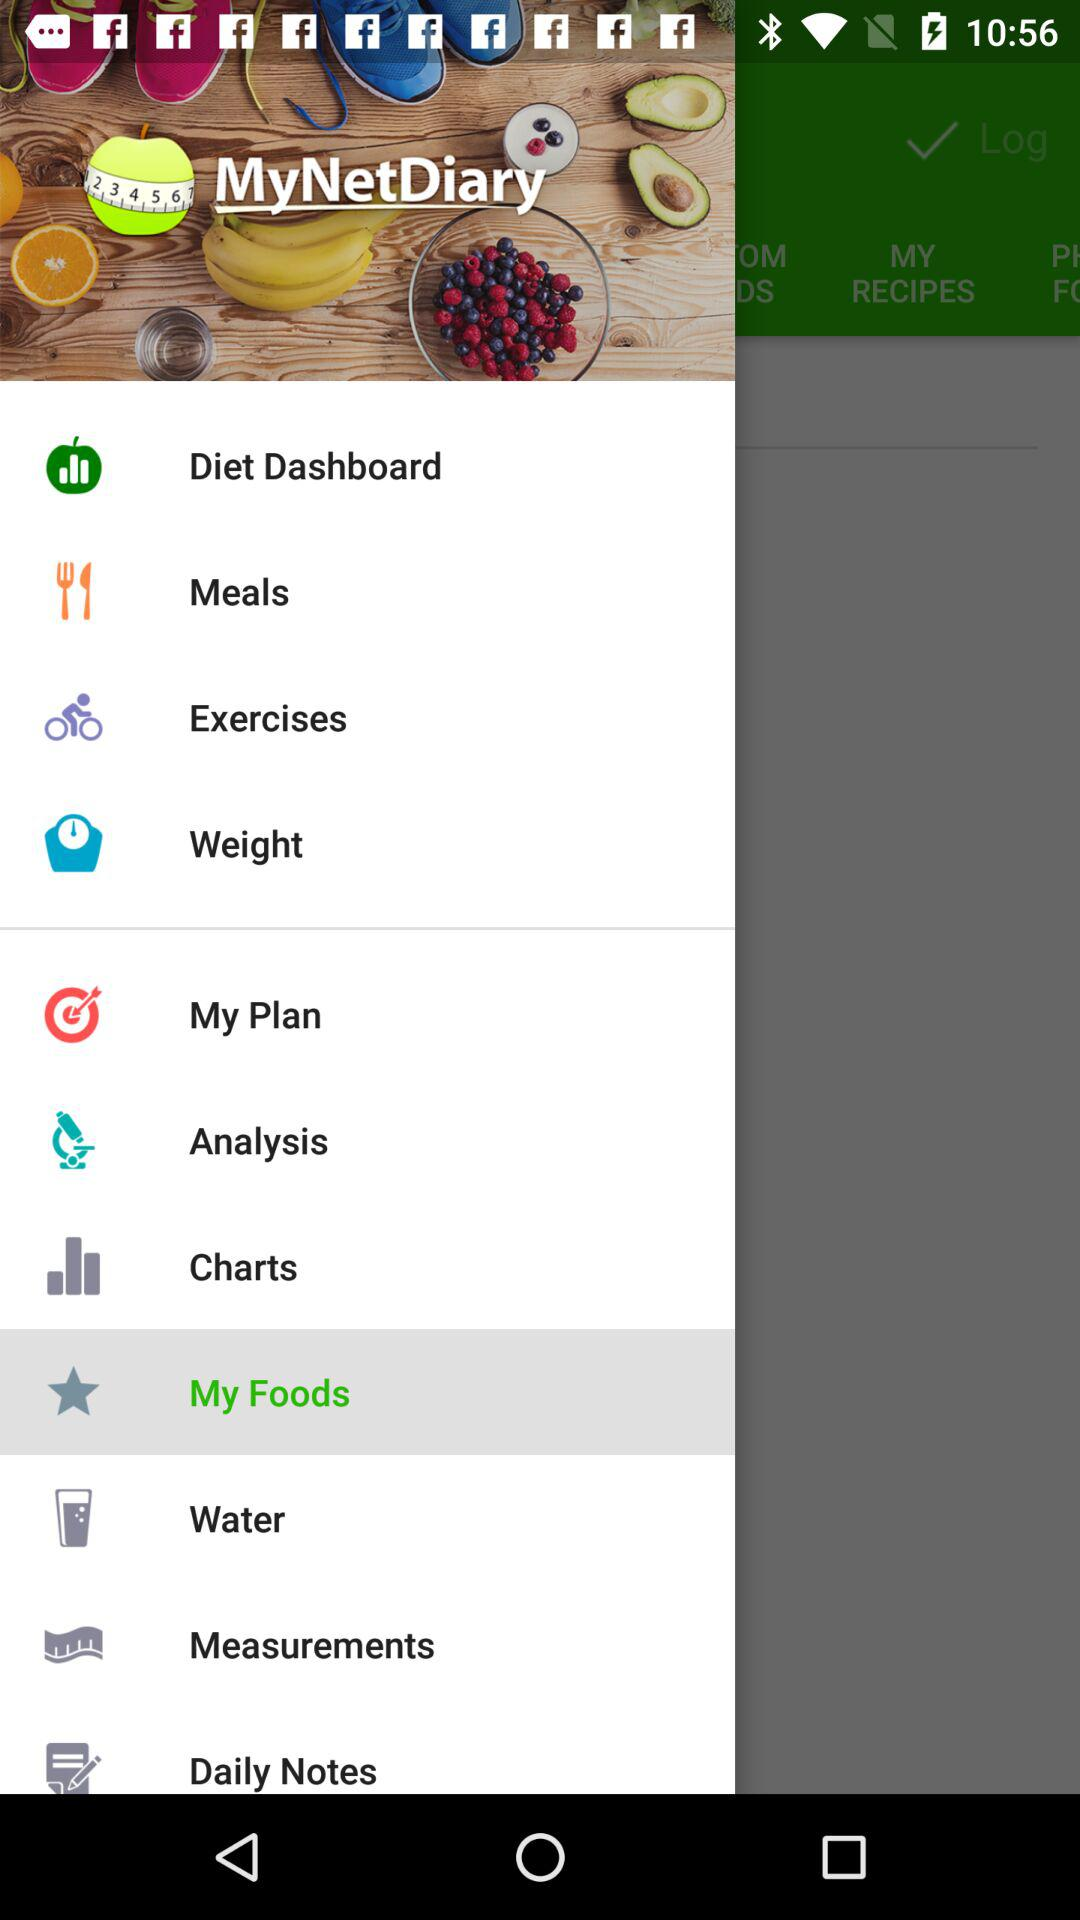Which is the selected item in the menu? The selected item is "My Foods". 